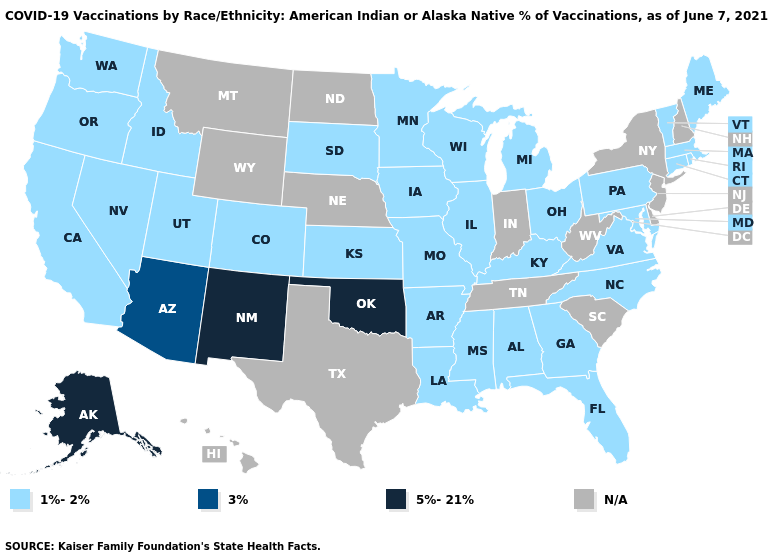What is the value of Minnesota?
Be succinct. 1%-2%. Name the states that have a value in the range 3%?
Give a very brief answer. Arizona. Which states have the highest value in the USA?
Keep it brief. Alaska, New Mexico, Oklahoma. Name the states that have a value in the range N/A?
Concise answer only. Delaware, Hawaii, Indiana, Montana, Nebraska, New Hampshire, New Jersey, New York, North Dakota, South Carolina, Tennessee, Texas, West Virginia, Wyoming. What is the value of Minnesota?
Concise answer only. 1%-2%. Which states have the lowest value in the South?
Answer briefly. Alabama, Arkansas, Florida, Georgia, Kentucky, Louisiana, Maryland, Mississippi, North Carolina, Virginia. Does Vermont have the highest value in the USA?
Be succinct. No. What is the value of Tennessee?
Quick response, please. N/A. Name the states that have a value in the range 3%?
Write a very short answer. Arizona. What is the value of Delaware?
Concise answer only. N/A. What is the value of Tennessee?
Answer briefly. N/A. Among the states that border Arizona , which have the lowest value?
Keep it brief. California, Colorado, Nevada, Utah. Does Oklahoma have the lowest value in the USA?
Give a very brief answer. No. Name the states that have a value in the range 1%-2%?
Give a very brief answer. Alabama, Arkansas, California, Colorado, Connecticut, Florida, Georgia, Idaho, Illinois, Iowa, Kansas, Kentucky, Louisiana, Maine, Maryland, Massachusetts, Michigan, Minnesota, Mississippi, Missouri, Nevada, North Carolina, Ohio, Oregon, Pennsylvania, Rhode Island, South Dakota, Utah, Vermont, Virginia, Washington, Wisconsin. What is the value of Tennessee?
Write a very short answer. N/A. 